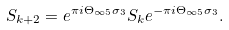Convert formula to latex. <formula><loc_0><loc_0><loc_500><loc_500>S _ { k + 2 } = e ^ { \pi i \Theta _ { \infty 5 } \sigma _ { 3 } } S _ { k } e ^ { - \pi i \Theta _ { \infty 5 } \sigma _ { 3 } } .</formula> 